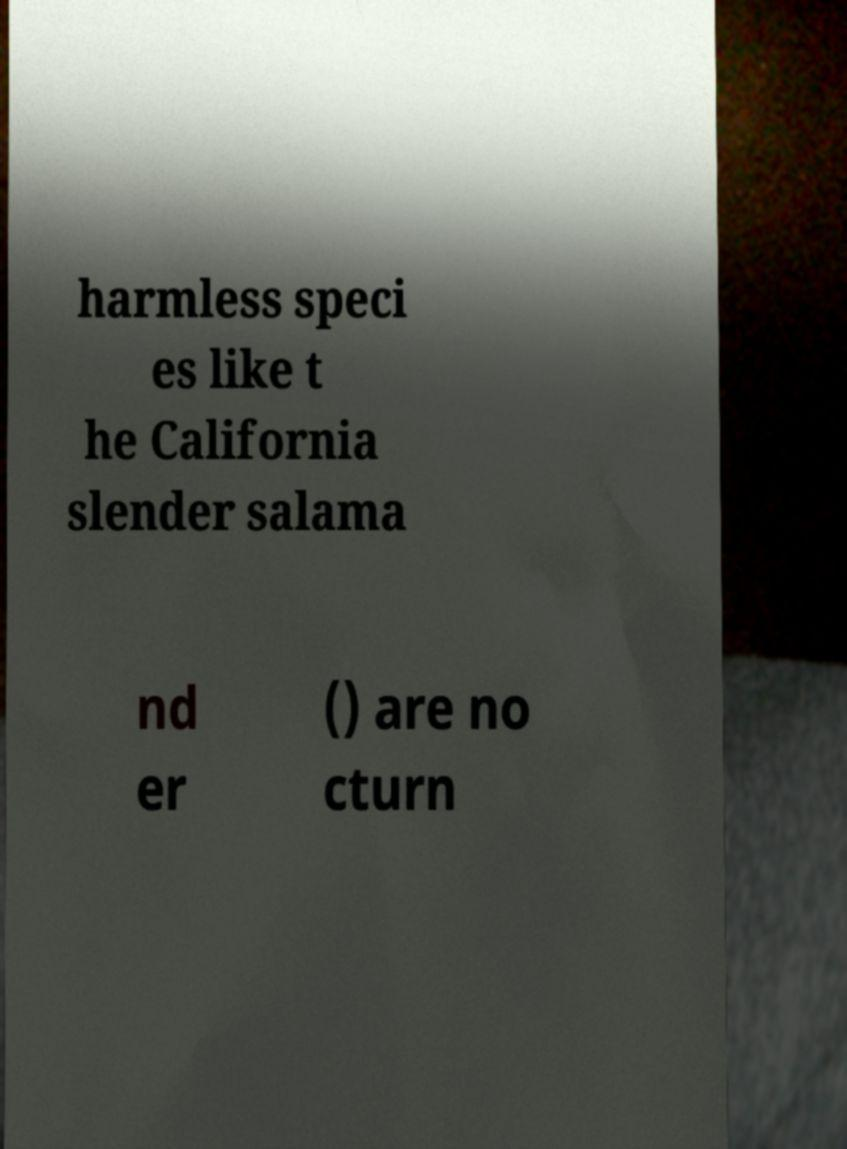Please identify and transcribe the text found in this image. harmless speci es like t he California slender salama nd er () are no cturn 